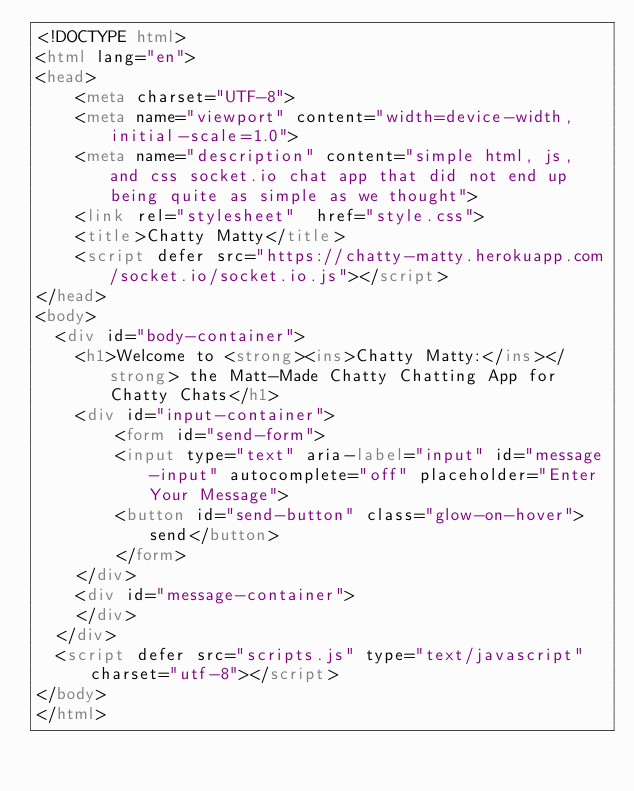<code> <loc_0><loc_0><loc_500><loc_500><_HTML_><!DOCTYPE html>
<html lang="en">
<head>
    <meta charset="UTF-8">
    <meta name="viewport" content="width=device-width, initial-scale=1.0">
    <meta name="description" content="simple html, js, and css socket.io chat app that did not end up being quite as simple as we thought">
    <link rel="stylesheet"  href="style.css">
    <title>Chatty Matty</title>
    <script defer src="https://chatty-matty.herokuapp.com/socket.io/socket.io.js"></script>
</head>
<body>
  <div id="body-container">
    <h1>Welcome to <strong><ins>Chatty Matty:</ins></strong> the Matt-Made Chatty Chatting App for Chatty Chats</h1>
    <div id="input-container">
        <form id="send-form">
        <input type="text" aria-label="input" id="message-input" autocomplete="off" placeholder="Enter Your Message">
        <button id="send-button" class="glow-on-hover">send</button>
        </form>
    </div>
    <div id="message-container">
    </div>    
  </div>
  <script defer src="scripts.js" type="text/javascript" charset="utf-8"></script>
</body>
</html></code> 